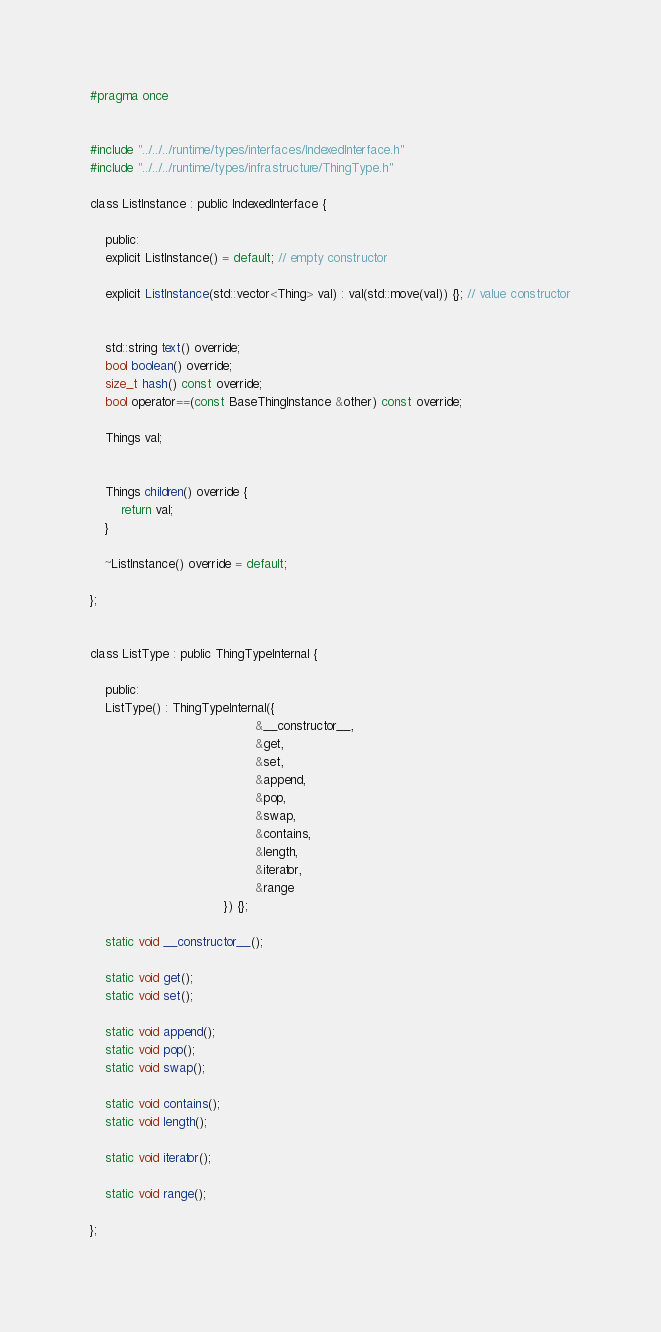Convert code to text. <code><loc_0><loc_0><loc_500><loc_500><_C_>#pragma once


#include "../../../runtime/types/interfaces/IndexedInterface.h"
#include "../../../runtime/types/infrastructure/ThingType.h"

class ListInstance : public IndexedInterface {
    
    public:
    explicit ListInstance() = default; // empty constructor
    
    explicit ListInstance(std::vector<Thing> val) : val(std::move(val)) {}; // value constructor


	std::string text() override;
	bool boolean() override;
	size_t hash() const override;
	bool operator==(const BaseThingInstance &other) const override;

    Things val;
    
    
    Things children() override {
        return val;
    }

	~ListInstance() override = default;

};


class ListType : public ThingTypeInternal {
    
    public:
    ListType() : ThingTypeInternal({
                                           &__constructor__,
                                           &get,
                                           &set,
                                           &append,
                                           &pop,
                                           &swap,
                                           &contains,
                                           &length,
                                           &iterator,
                                           &range
                                   }) {};
 
	static void __constructor__();

    static void get();
    static void set();

	static void append();
	static void pop();
    static void swap();

	static void contains();
    static void length();

	static void iterator();

	static void range();
    
};
</code> 